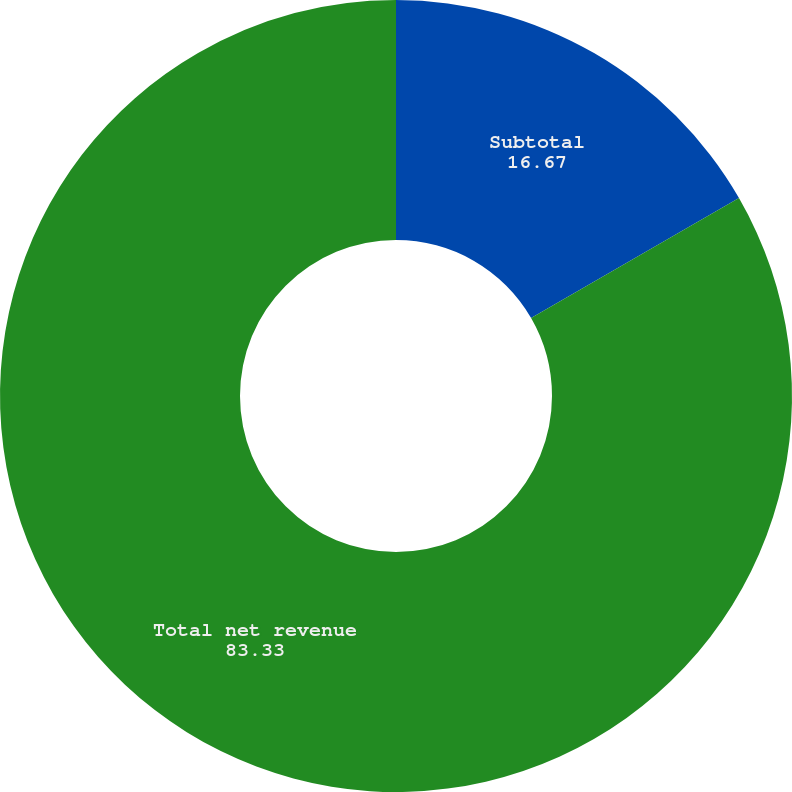Convert chart. <chart><loc_0><loc_0><loc_500><loc_500><pie_chart><fcel>Subtotal<fcel>Total net revenue<nl><fcel>16.67%<fcel>83.33%<nl></chart> 